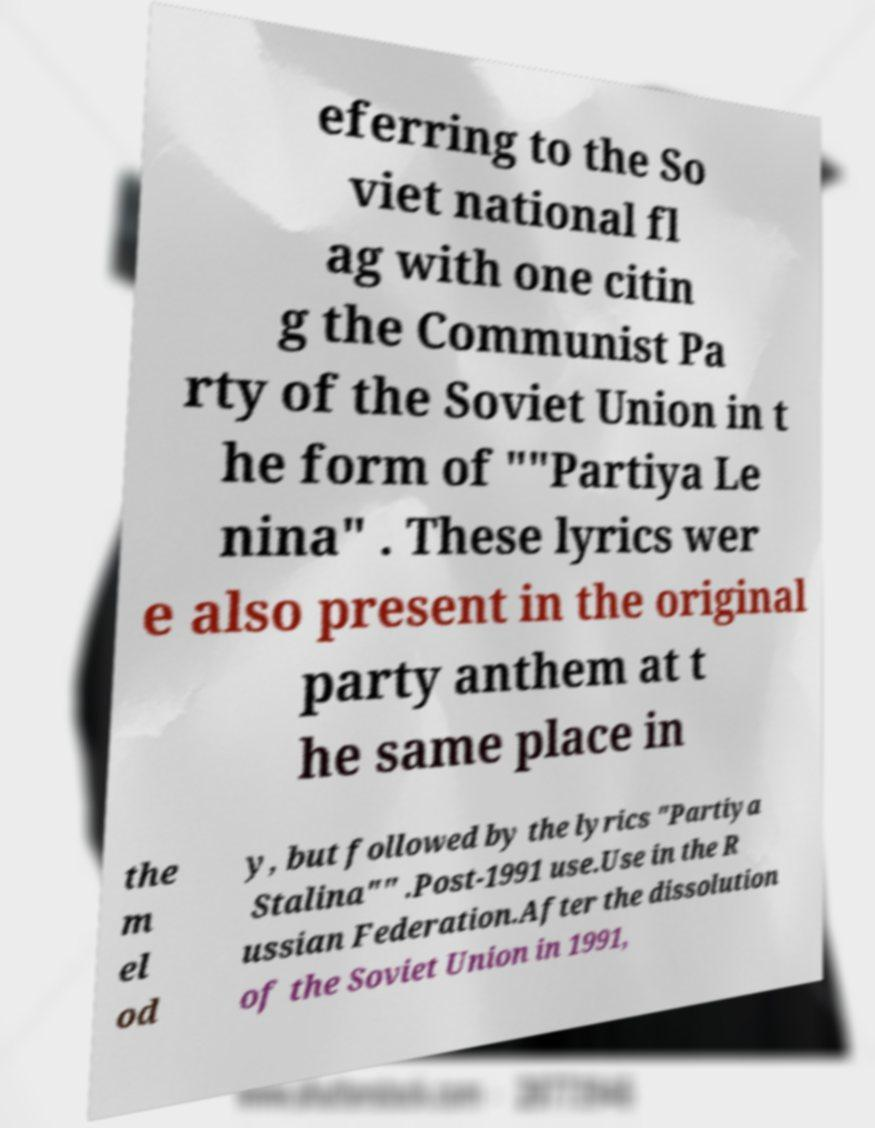For documentation purposes, I need the text within this image transcribed. Could you provide that? eferring to the So viet national fl ag with one citin g the Communist Pa rty of the Soviet Union in t he form of ""Partiya Le nina" . These lyrics wer e also present in the original party anthem at t he same place in the m el od y, but followed by the lyrics "Partiya Stalina"" .Post-1991 use.Use in the R ussian Federation.After the dissolution of the Soviet Union in 1991, 